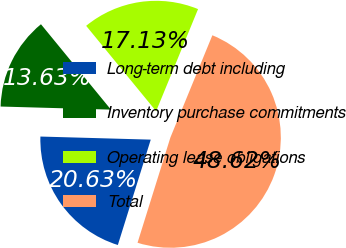<chart> <loc_0><loc_0><loc_500><loc_500><pie_chart><fcel>Long-term debt including<fcel>Inventory purchase commitments<fcel>Operating lease obligations<fcel>Total<nl><fcel>20.63%<fcel>13.63%<fcel>17.13%<fcel>48.62%<nl></chart> 